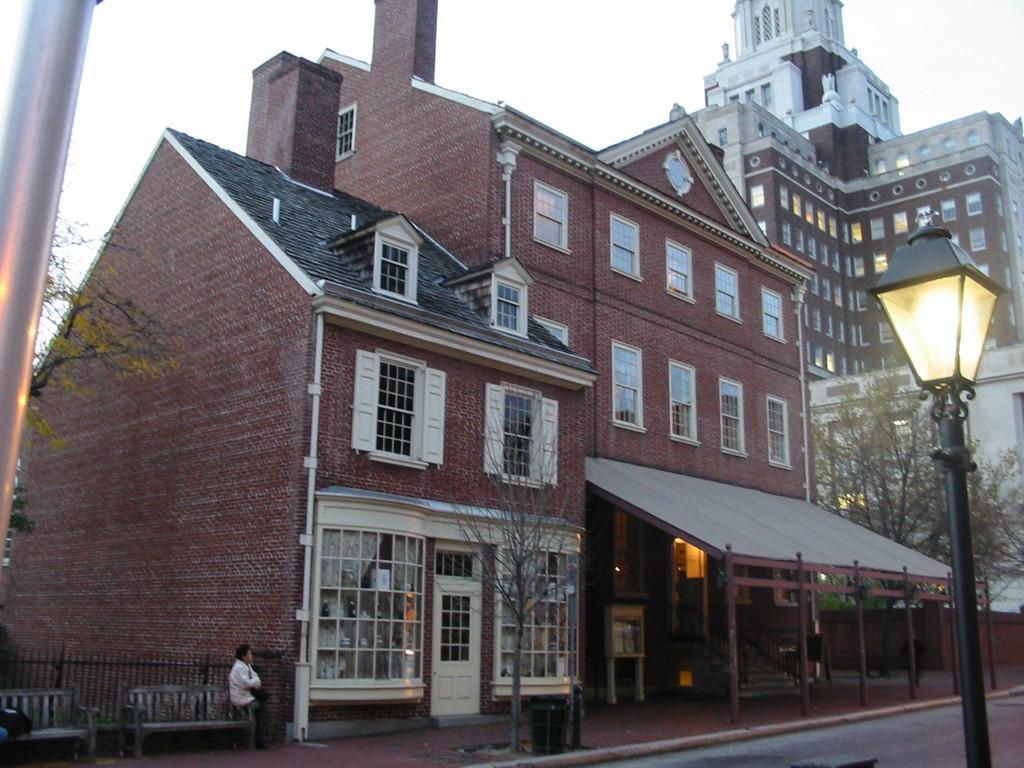In one or two sentences, can you explain what this image depicts? In this image we can see two buildings with glass windows. In front of the building road is present and one black color pole with light is there. To the left side of the image girl and two benches are there. On one bench one person is siting and trees are present. 